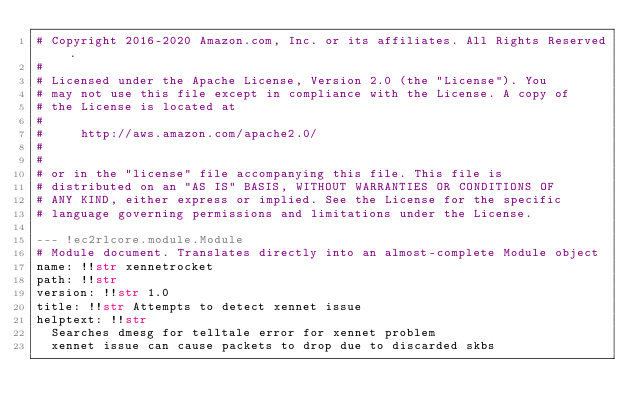Convert code to text. <code><loc_0><loc_0><loc_500><loc_500><_YAML_># Copyright 2016-2020 Amazon.com, Inc. or its affiliates. All Rights Reserved.
#
# Licensed under the Apache License, Version 2.0 (the "License"). You
# may not use this file except in compliance with the License. A copy of
# the License is located at
#
#     http://aws.amazon.com/apache2.0/
#
#
# or in the "license" file accompanying this file. This file is
# distributed on an "AS IS" BASIS, WITHOUT WARRANTIES OR CONDITIONS OF
# ANY KIND, either express or implied. See the License for the specific
# language governing permissions and limitations under the License.

--- !ec2rlcore.module.Module
# Module document. Translates directly into an almost-complete Module object
name: !!str xennetrocket
path: !!str
version: !!str 1.0
title: !!str Attempts to detect xennet issue
helptext: !!str
  Searches dmesg for telltale error for xennet problem
  xennet issue can cause packets to drop due to discarded skbs</code> 